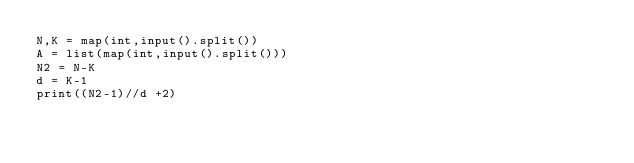<code> <loc_0><loc_0><loc_500><loc_500><_Python_>N,K = map(int,input().split())
A = list(map(int,input().split()))
N2 = N-K
d = K-1
print((N2-1)//d +2)</code> 